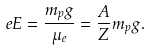<formula> <loc_0><loc_0><loc_500><loc_500>e E = \frac { m _ { p } g } { \mu _ { e } } = \frac { A } { Z } m _ { p } g .</formula> 